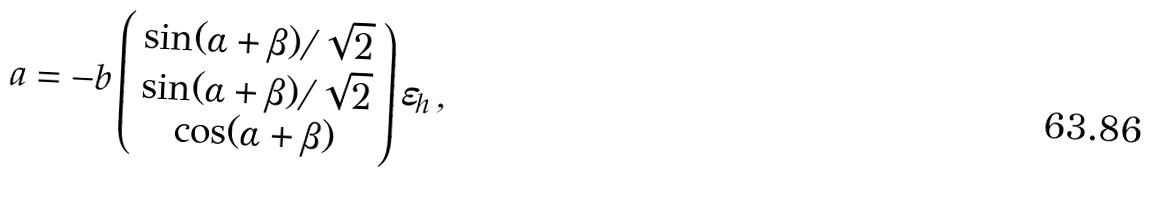Convert formula to latex. <formula><loc_0><loc_0><loc_500><loc_500>a = - b \left ( \begin{array} { c } \sin ( \alpha + \beta ) / \sqrt { 2 } \\ \sin ( \alpha + \beta ) / \sqrt { 2 } \\ \cos ( \alpha + \beta ) \\ \end{array} \right ) \varepsilon _ { h } \, ,</formula> 